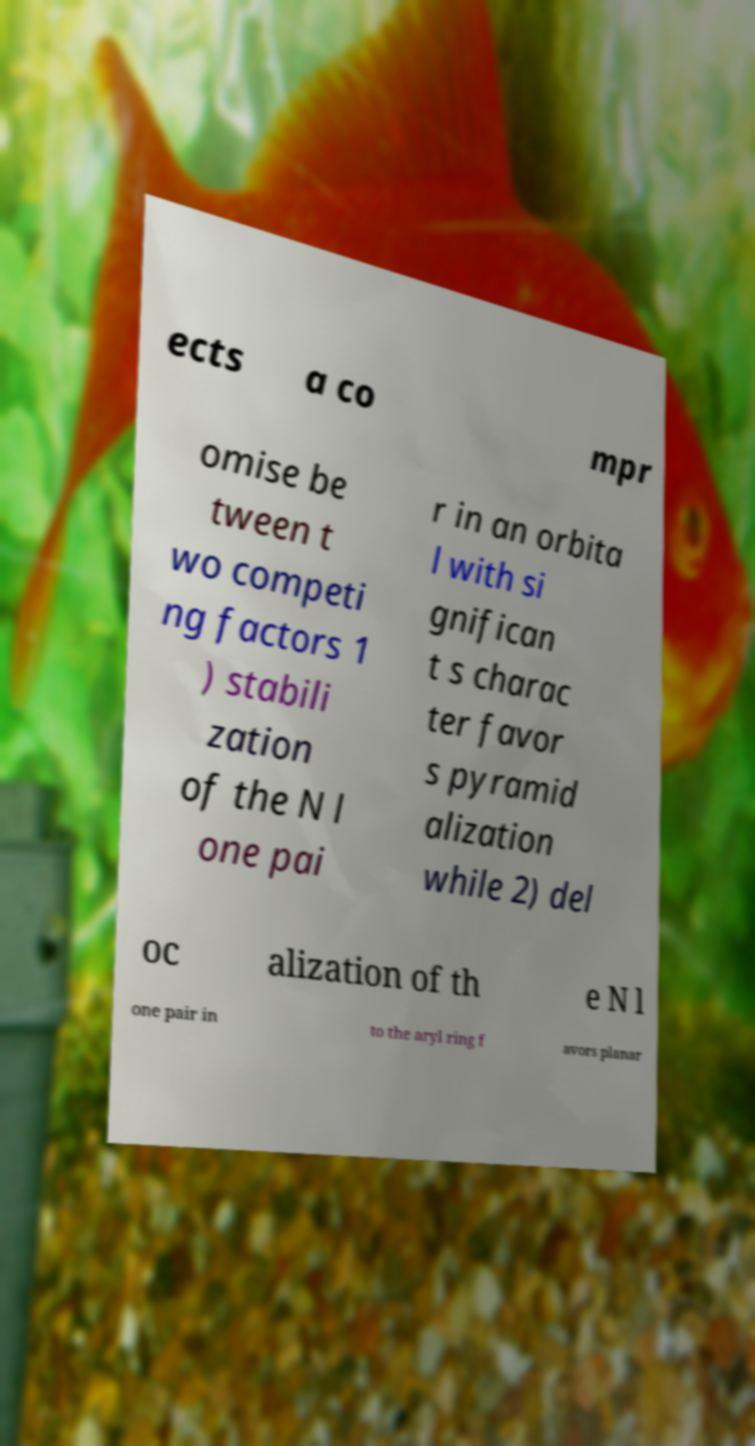Could you assist in decoding the text presented in this image and type it out clearly? ects a co mpr omise be tween t wo competi ng factors 1 ) stabili zation of the N l one pai r in an orbita l with si gnifican t s charac ter favor s pyramid alization while 2) del oc alization of th e N l one pair in to the aryl ring f avors planar 